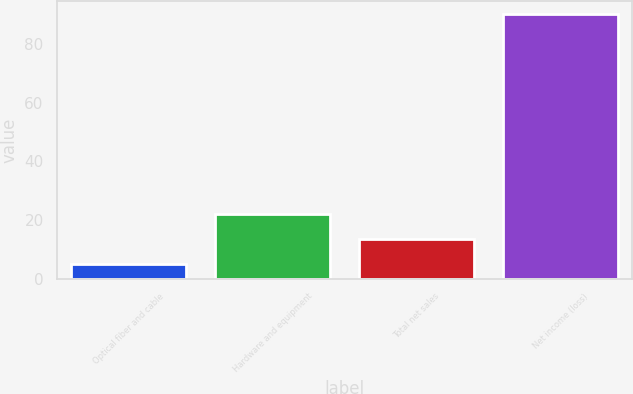<chart> <loc_0><loc_0><loc_500><loc_500><bar_chart><fcel>Optical fiber and cable<fcel>Hardware and equipment<fcel>Total net sales<fcel>Net income (loss)<nl><fcel>5<fcel>22<fcel>13.5<fcel>90<nl></chart> 